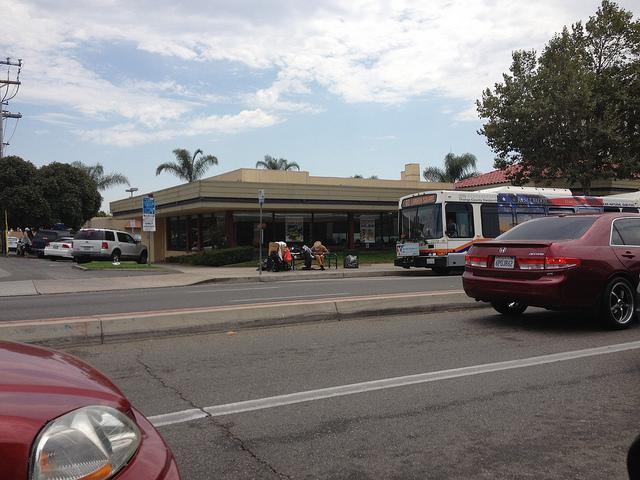How many cars are there?
Give a very brief answer. 3. 